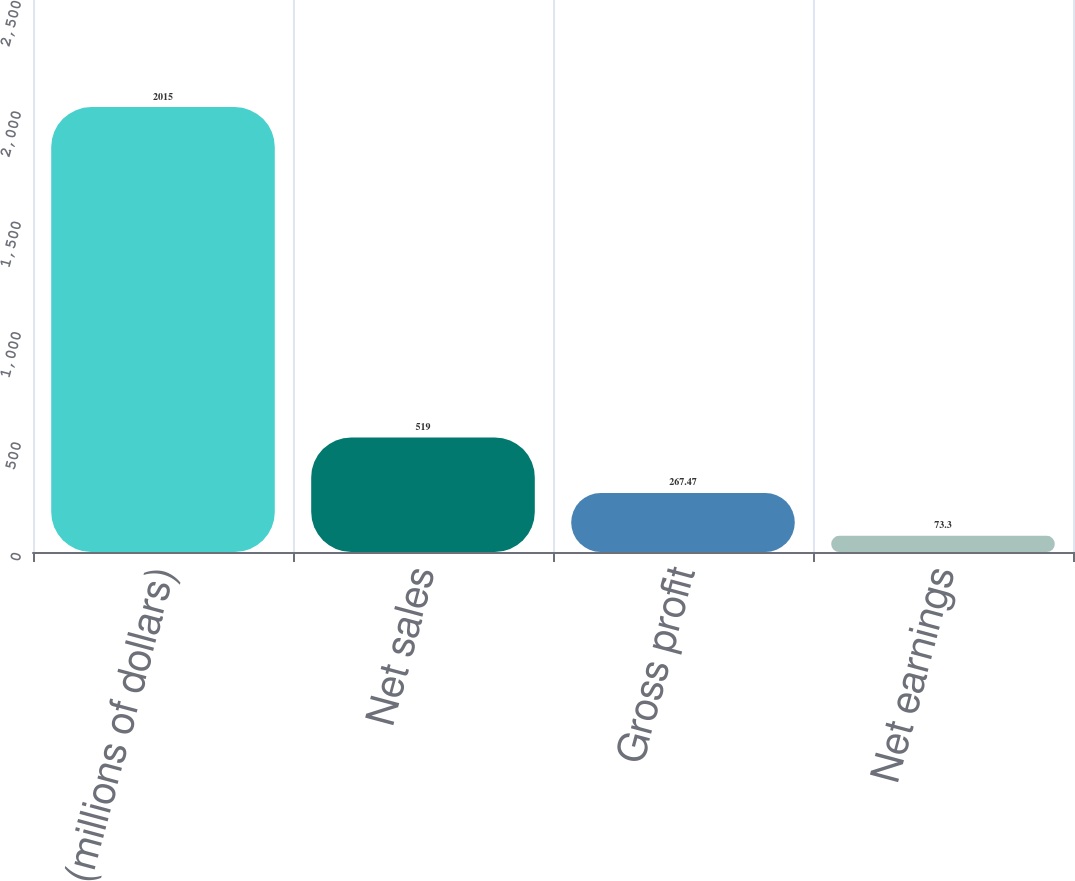Convert chart to OTSL. <chart><loc_0><loc_0><loc_500><loc_500><bar_chart><fcel>(millions of dollars)<fcel>Net sales<fcel>Gross profit<fcel>Net earnings<nl><fcel>2015<fcel>519<fcel>267.47<fcel>73.3<nl></chart> 